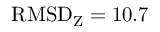<formula> <loc_0><loc_0><loc_500><loc_500>R M S D _ { Z } = 1 0 . 7</formula> 